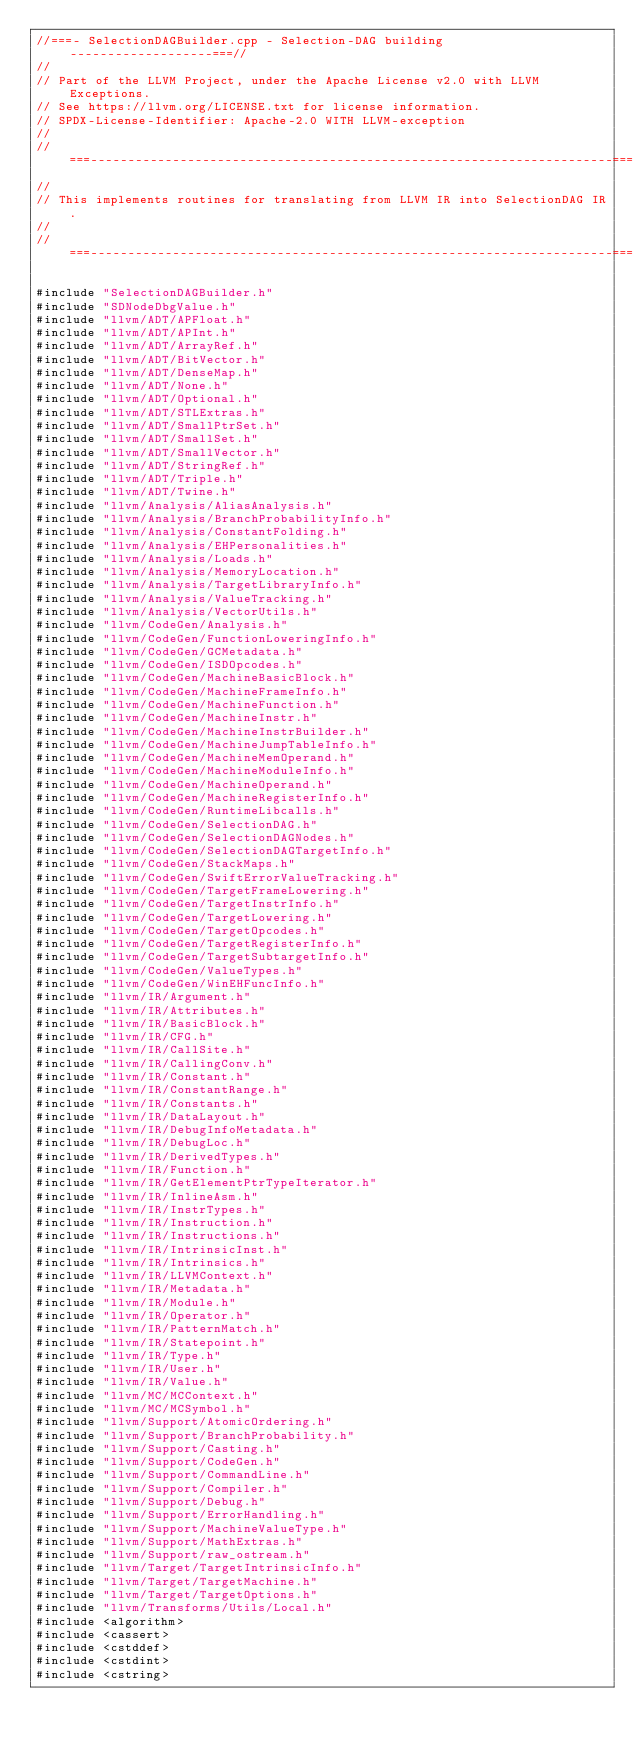Convert code to text. <code><loc_0><loc_0><loc_500><loc_500><_C++_>//===- SelectionDAGBuilder.cpp - Selection-DAG building -------------------===//
//
// Part of the LLVM Project, under the Apache License v2.0 with LLVM Exceptions.
// See https://llvm.org/LICENSE.txt for license information.
// SPDX-License-Identifier: Apache-2.0 WITH LLVM-exception
//
//===----------------------------------------------------------------------===//
//
// This implements routines for translating from LLVM IR into SelectionDAG IR.
//
//===----------------------------------------------------------------------===//

#include "SelectionDAGBuilder.h"
#include "SDNodeDbgValue.h"
#include "llvm/ADT/APFloat.h"
#include "llvm/ADT/APInt.h"
#include "llvm/ADT/ArrayRef.h"
#include "llvm/ADT/BitVector.h"
#include "llvm/ADT/DenseMap.h"
#include "llvm/ADT/None.h"
#include "llvm/ADT/Optional.h"
#include "llvm/ADT/STLExtras.h"
#include "llvm/ADT/SmallPtrSet.h"
#include "llvm/ADT/SmallSet.h"
#include "llvm/ADT/SmallVector.h"
#include "llvm/ADT/StringRef.h"
#include "llvm/ADT/Triple.h"
#include "llvm/ADT/Twine.h"
#include "llvm/Analysis/AliasAnalysis.h"
#include "llvm/Analysis/BranchProbabilityInfo.h"
#include "llvm/Analysis/ConstantFolding.h"
#include "llvm/Analysis/EHPersonalities.h"
#include "llvm/Analysis/Loads.h"
#include "llvm/Analysis/MemoryLocation.h"
#include "llvm/Analysis/TargetLibraryInfo.h"
#include "llvm/Analysis/ValueTracking.h"
#include "llvm/Analysis/VectorUtils.h"
#include "llvm/CodeGen/Analysis.h"
#include "llvm/CodeGen/FunctionLoweringInfo.h"
#include "llvm/CodeGen/GCMetadata.h"
#include "llvm/CodeGen/ISDOpcodes.h"
#include "llvm/CodeGen/MachineBasicBlock.h"
#include "llvm/CodeGen/MachineFrameInfo.h"
#include "llvm/CodeGen/MachineFunction.h"
#include "llvm/CodeGen/MachineInstr.h"
#include "llvm/CodeGen/MachineInstrBuilder.h"
#include "llvm/CodeGen/MachineJumpTableInfo.h"
#include "llvm/CodeGen/MachineMemOperand.h"
#include "llvm/CodeGen/MachineModuleInfo.h"
#include "llvm/CodeGen/MachineOperand.h"
#include "llvm/CodeGen/MachineRegisterInfo.h"
#include "llvm/CodeGen/RuntimeLibcalls.h"
#include "llvm/CodeGen/SelectionDAG.h"
#include "llvm/CodeGen/SelectionDAGNodes.h"
#include "llvm/CodeGen/SelectionDAGTargetInfo.h"
#include "llvm/CodeGen/StackMaps.h"
#include "llvm/CodeGen/SwiftErrorValueTracking.h"
#include "llvm/CodeGen/TargetFrameLowering.h"
#include "llvm/CodeGen/TargetInstrInfo.h"
#include "llvm/CodeGen/TargetLowering.h"
#include "llvm/CodeGen/TargetOpcodes.h"
#include "llvm/CodeGen/TargetRegisterInfo.h"
#include "llvm/CodeGen/TargetSubtargetInfo.h"
#include "llvm/CodeGen/ValueTypes.h"
#include "llvm/CodeGen/WinEHFuncInfo.h"
#include "llvm/IR/Argument.h"
#include "llvm/IR/Attributes.h"
#include "llvm/IR/BasicBlock.h"
#include "llvm/IR/CFG.h"
#include "llvm/IR/CallSite.h"
#include "llvm/IR/CallingConv.h"
#include "llvm/IR/Constant.h"
#include "llvm/IR/ConstantRange.h"
#include "llvm/IR/Constants.h"
#include "llvm/IR/DataLayout.h"
#include "llvm/IR/DebugInfoMetadata.h"
#include "llvm/IR/DebugLoc.h"
#include "llvm/IR/DerivedTypes.h"
#include "llvm/IR/Function.h"
#include "llvm/IR/GetElementPtrTypeIterator.h"
#include "llvm/IR/InlineAsm.h"
#include "llvm/IR/InstrTypes.h"
#include "llvm/IR/Instruction.h"
#include "llvm/IR/Instructions.h"
#include "llvm/IR/IntrinsicInst.h"
#include "llvm/IR/Intrinsics.h"
#include "llvm/IR/LLVMContext.h"
#include "llvm/IR/Metadata.h"
#include "llvm/IR/Module.h"
#include "llvm/IR/Operator.h"
#include "llvm/IR/PatternMatch.h"
#include "llvm/IR/Statepoint.h"
#include "llvm/IR/Type.h"
#include "llvm/IR/User.h"
#include "llvm/IR/Value.h"
#include "llvm/MC/MCContext.h"
#include "llvm/MC/MCSymbol.h"
#include "llvm/Support/AtomicOrdering.h"
#include "llvm/Support/BranchProbability.h"
#include "llvm/Support/Casting.h"
#include "llvm/Support/CodeGen.h"
#include "llvm/Support/CommandLine.h"
#include "llvm/Support/Compiler.h"
#include "llvm/Support/Debug.h"
#include "llvm/Support/ErrorHandling.h"
#include "llvm/Support/MachineValueType.h"
#include "llvm/Support/MathExtras.h"
#include "llvm/Support/raw_ostream.h"
#include "llvm/Target/TargetIntrinsicInfo.h"
#include "llvm/Target/TargetMachine.h"
#include "llvm/Target/TargetOptions.h"
#include "llvm/Transforms/Utils/Local.h"
#include <algorithm>
#include <cassert>
#include <cstddef>
#include <cstdint>
#include <cstring></code> 